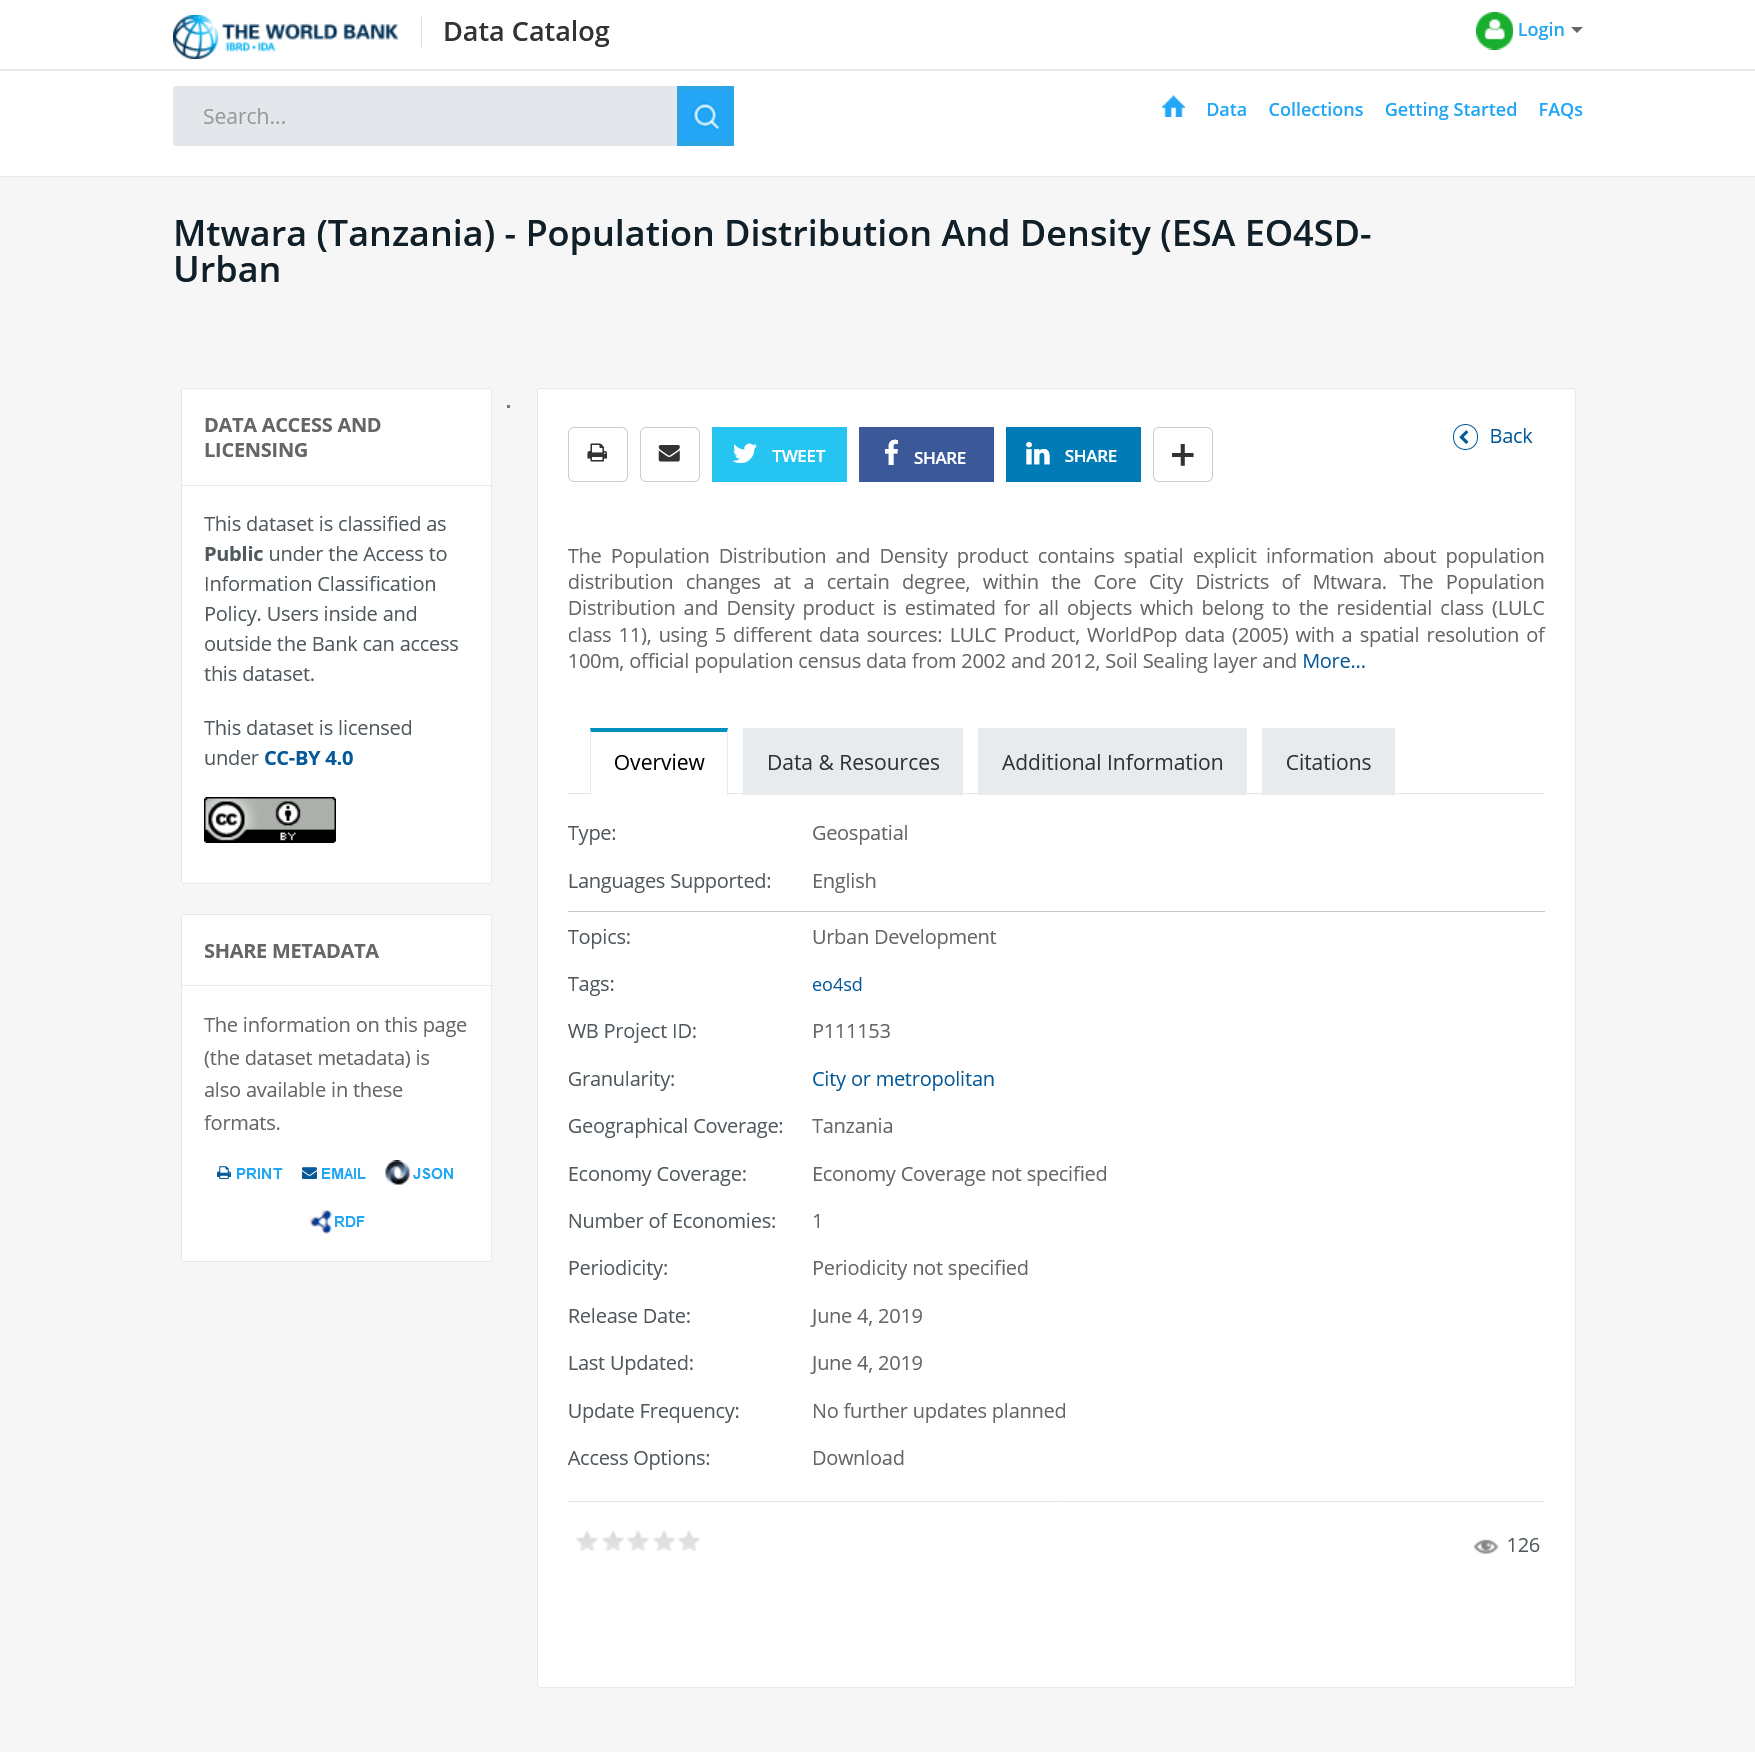Outline some significant characteristics in this image. The Core City Districts of Mtwara is located in the country of Tanzania. The Population Distribution and Density dataset provides information on population distribution changes within the Core City Districts of the city of Mtwara. The Population Distribution and Density product is publicly available under the Access to Information Classification Policy. 